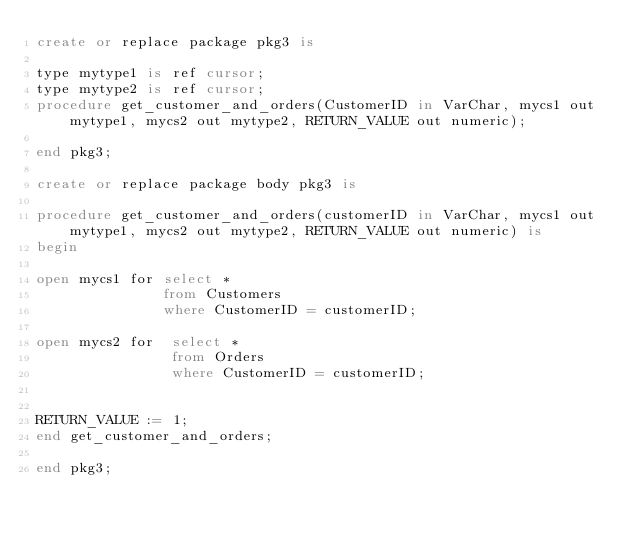Convert code to text. <code><loc_0><loc_0><loc_500><loc_500><_SQL_>create or replace package pkg3 is

type mytype1 is ref cursor;
type mytype2 is ref cursor;
procedure get_customer_and_orders(CustomerID in VarChar, mycs1 out mytype1, mycs2 out mytype2, RETURN_VALUE out numeric);

end pkg3;

create or replace package body pkg3 is

procedure get_customer_and_orders(customerID in VarChar, mycs1 out mytype1, mycs2 out mytype2, RETURN_VALUE out numeric) is
begin

open mycs1 for select *
               from Customers
               where CustomerID = customerID;
                   
open mycs2 for  select *
                from Orders 
                where CustomerID = customerID; 
  
           
RETURN_VALUE := 1;                       
end get_customer_and_orders;

end pkg3;</code> 